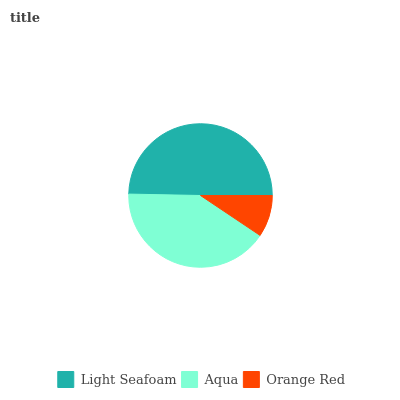Is Orange Red the minimum?
Answer yes or no. Yes. Is Light Seafoam the maximum?
Answer yes or no. Yes. Is Aqua the minimum?
Answer yes or no. No. Is Aqua the maximum?
Answer yes or no. No. Is Light Seafoam greater than Aqua?
Answer yes or no. Yes. Is Aqua less than Light Seafoam?
Answer yes or no. Yes. Is Aqua greater than Light Seafoam?
Answer yes or no. No. Is Light Seafoam less than Aqua?
Answer yes or no. No. Is Aqua the high median?
Answer yes or no. Yes. Is Aqua the low median?
Answer yes or no. Yes. Is Orange Red the high median?
Answer yes or no. No. Is Light Seafoam the low median?
Answer yes or no. No. 